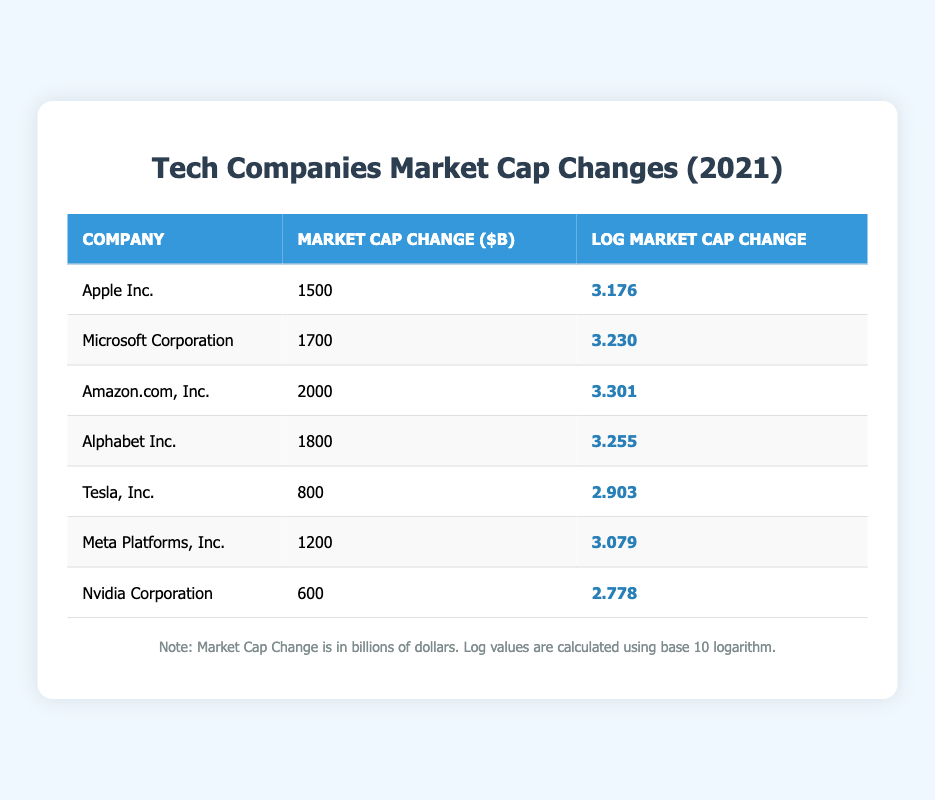What is the market cap change for Amazon.com, Inc.? The table lists the market cap change for each company. Looking at the row for Amazon.com, Inc., the market cap change is indicated as 2000 billion dollars.
Answer: 2000 Which company had the highest log market cap change value? By examining the "Log Market Cap Change" column, I can see the values for each company. The highest value is 3.301, which corresponds to Amazon.com, Inc.
Answer: Amazon.com, Inc What is the total market cap change of Apple Inc. and Meta Platforms, Inc.? The market cap changes for Apple Inc. and Meta Platforms, Inc. are 1500 billion and 1200 billion, respectively. Adding these together (1500 + 1200) gives a total of 2700 billion dollars.
Answer: 2700 Is the log market cap change for Tesla, Inc. greater than 3? The log market cap change for Tesla, Inc. is specified as 2.903. Since this value is lower than 3, the answer is no.
Answer: No What is the difference between the log market cap change of Microsoft Corporation and Nvidia Corporation? The log market cap change for Microsoft Corporation is 3.230, while for Nvidia Corporation, it is 2.778. Subtracting these values (3.230 - 2.778) gives a difference of 0.452.
Answer: 0.452 Which companies had a market cap change of less than 1000 billion dollars? By reviewing the market cap change values, I can see that Tesla, Inc. has a change of 800 billion and Nvidia Corporation has 600 billion. Both are below 1000 billion dollars.
Answer: Tesla, Inc. and Nvidia Corporation What is the average market cap change for the five highest companies by market cap change? The five companies with the highest market cap changes are Amazon.com, Inc. (2000), Microsoft Corporation (1700), Alphabet Inc. (1800), Apple Inc. (1500), and Meta Platforms, Inc. (1200). Summing these values gives 2000 + 1700 + 1800 + 1500 + 1200 = 10200 billion. Dividing by 5 (number of companies) gives 10200 / 5 = 2040 billion.
Answer: 2040 Was Nvidia Corporation's market cap change greater than or equal to 1200 billion dollars? The market cap change for Nvidia Corporation is listed as 600 billion dollars, which is less than 1200 billion dollars. Therefore, the answer is no.
Answer: No 